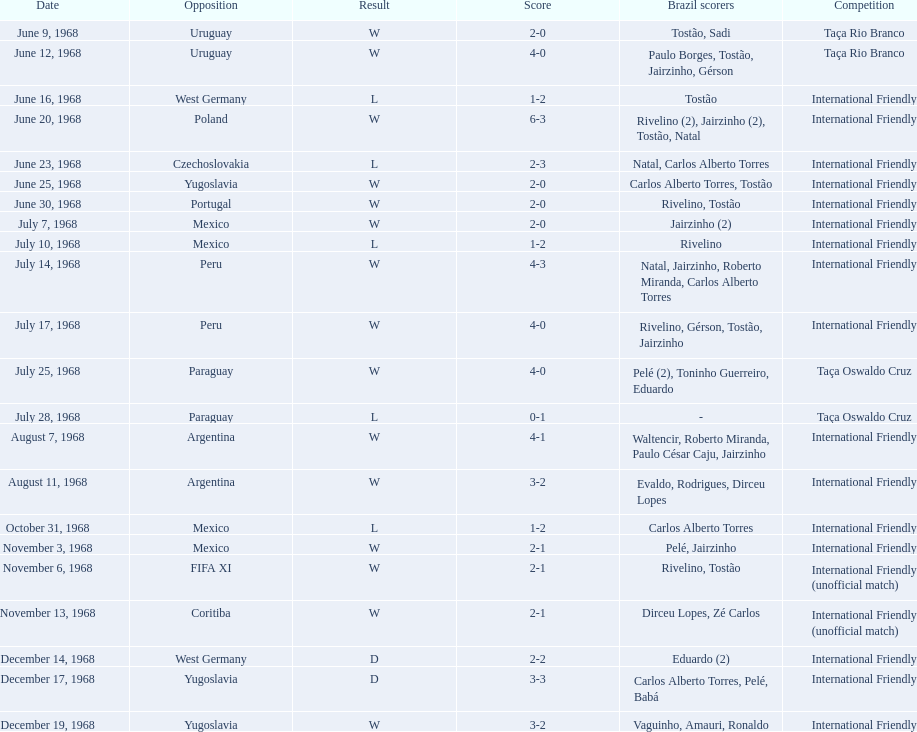What is the overall count of ties? 2. Parse the full table. {'header': ['Date', 'Opposition', 'Result', 'Score', 'Brazil scorers', 'Competition'], 'rows': [['June 9, 1968', 'Uruguay', 'W', '2-0', 'Tostão, Sadi', 'Taça Rio Branco'], ['June 12, 1968', 'Uruguay', 'W', '4-0', 'Paulo Borges, Tostão, Jairzinho, Gérson', 'Taça Rio Branco'], ['June 16, 1968', 'West Germany', 'L', '1-2', 'Tostão', 'International Friendly'], ['June 20, 1968', 'Poland', 'W', '6-3', 'Rivelino (2), Jairzinho (2), Tostão, Natal', 'International Friendly'], ['June 23, 1968', 'Czechoslovakia', 'L', '2-3', 'Natal, Carlos Alberto Torres', 'International Friendly'], ['June 25, 1968', 'Yugoslavia', 'W', '2-0', 'Carlos Alberto Torres, Tostão', 'International Friendly'], ['June 30, 1968', 'Portugal', 'W', '2-0', 'Rivelino, Tostão', 'International Friendly'], ['July 7, 1968', 'Mexico', 'W', '2-0', 'Jairzinho (2)', 'International Friendly'], ['July 10, 1968', 'Mexico', 'L', '1-2', 'Rivelino', 'International Friendly'], ['July 14, 1968', 'Peru', 'W', '4-3', 'Natal, Jairzinho, Roberto Miranda, Carlos Alberto Torres', 'International Friendly'], ['July 17, 1968', 'Peru', 'W', '4-0', 'Rivelino, Gérson, Tostão, Jairzinho', 'International Friendly'], ['July 25, 1968', 'Paraguay', 'W', '4-0', 'Pelé (2), Toninho Guerreiro, Eduardo', 'Taça Oswaldo Cruz'], ['July 28, 1968', 'Paraguay', 'L', '0-1', '-', 'Taça Oswaldo Cruz'], ['August 7, 1968', 'Argentina', 'W', '4-1', 'Waltencir, Roberto Miranda, Paulo César Caju, Jairzinho', 'International Friendly'], ['August 11, 1968', 'Argentina', 'W', '3-2', 'Evaldo, Rodrigues, Dirceu Lopes', 'International Friendly'], ['October 31, 1968', 'Mexico', 'L', '1-2', 'Carlos Alberto Torres', 'International Friendly'], ['November 3, 1968', 'Mexico', 'W', '2-1', 'Pelé, Jairzinho', 'International Friendly'], ['November 6, 1968', 'FIFA XI', 'W', '2-1', 'Rivelino, Tostão', 'International Friendly (unofficial match)'], ['November 13, 1968', 'Coritiba', 'W', '2-1', 'Dirceu Lopes, Zé Carlos', 'International Friendly (unofficial match)'], ['December 14, 1968', 'West Germany', 'D', '2-2', 'Eduardo (2)', 'International Friendly'], ['December 17, 1968', 'Yugoslavia', 'D', '3-3', 'Carlos Alberto Torres, Pelé, Babá', 'International Friendly'], ['December 19, 1968', 'Yugoslavia', 'W', '3-2', 'Vaguinho, Amauri, Ronaldo', 'International Friendly']]} 